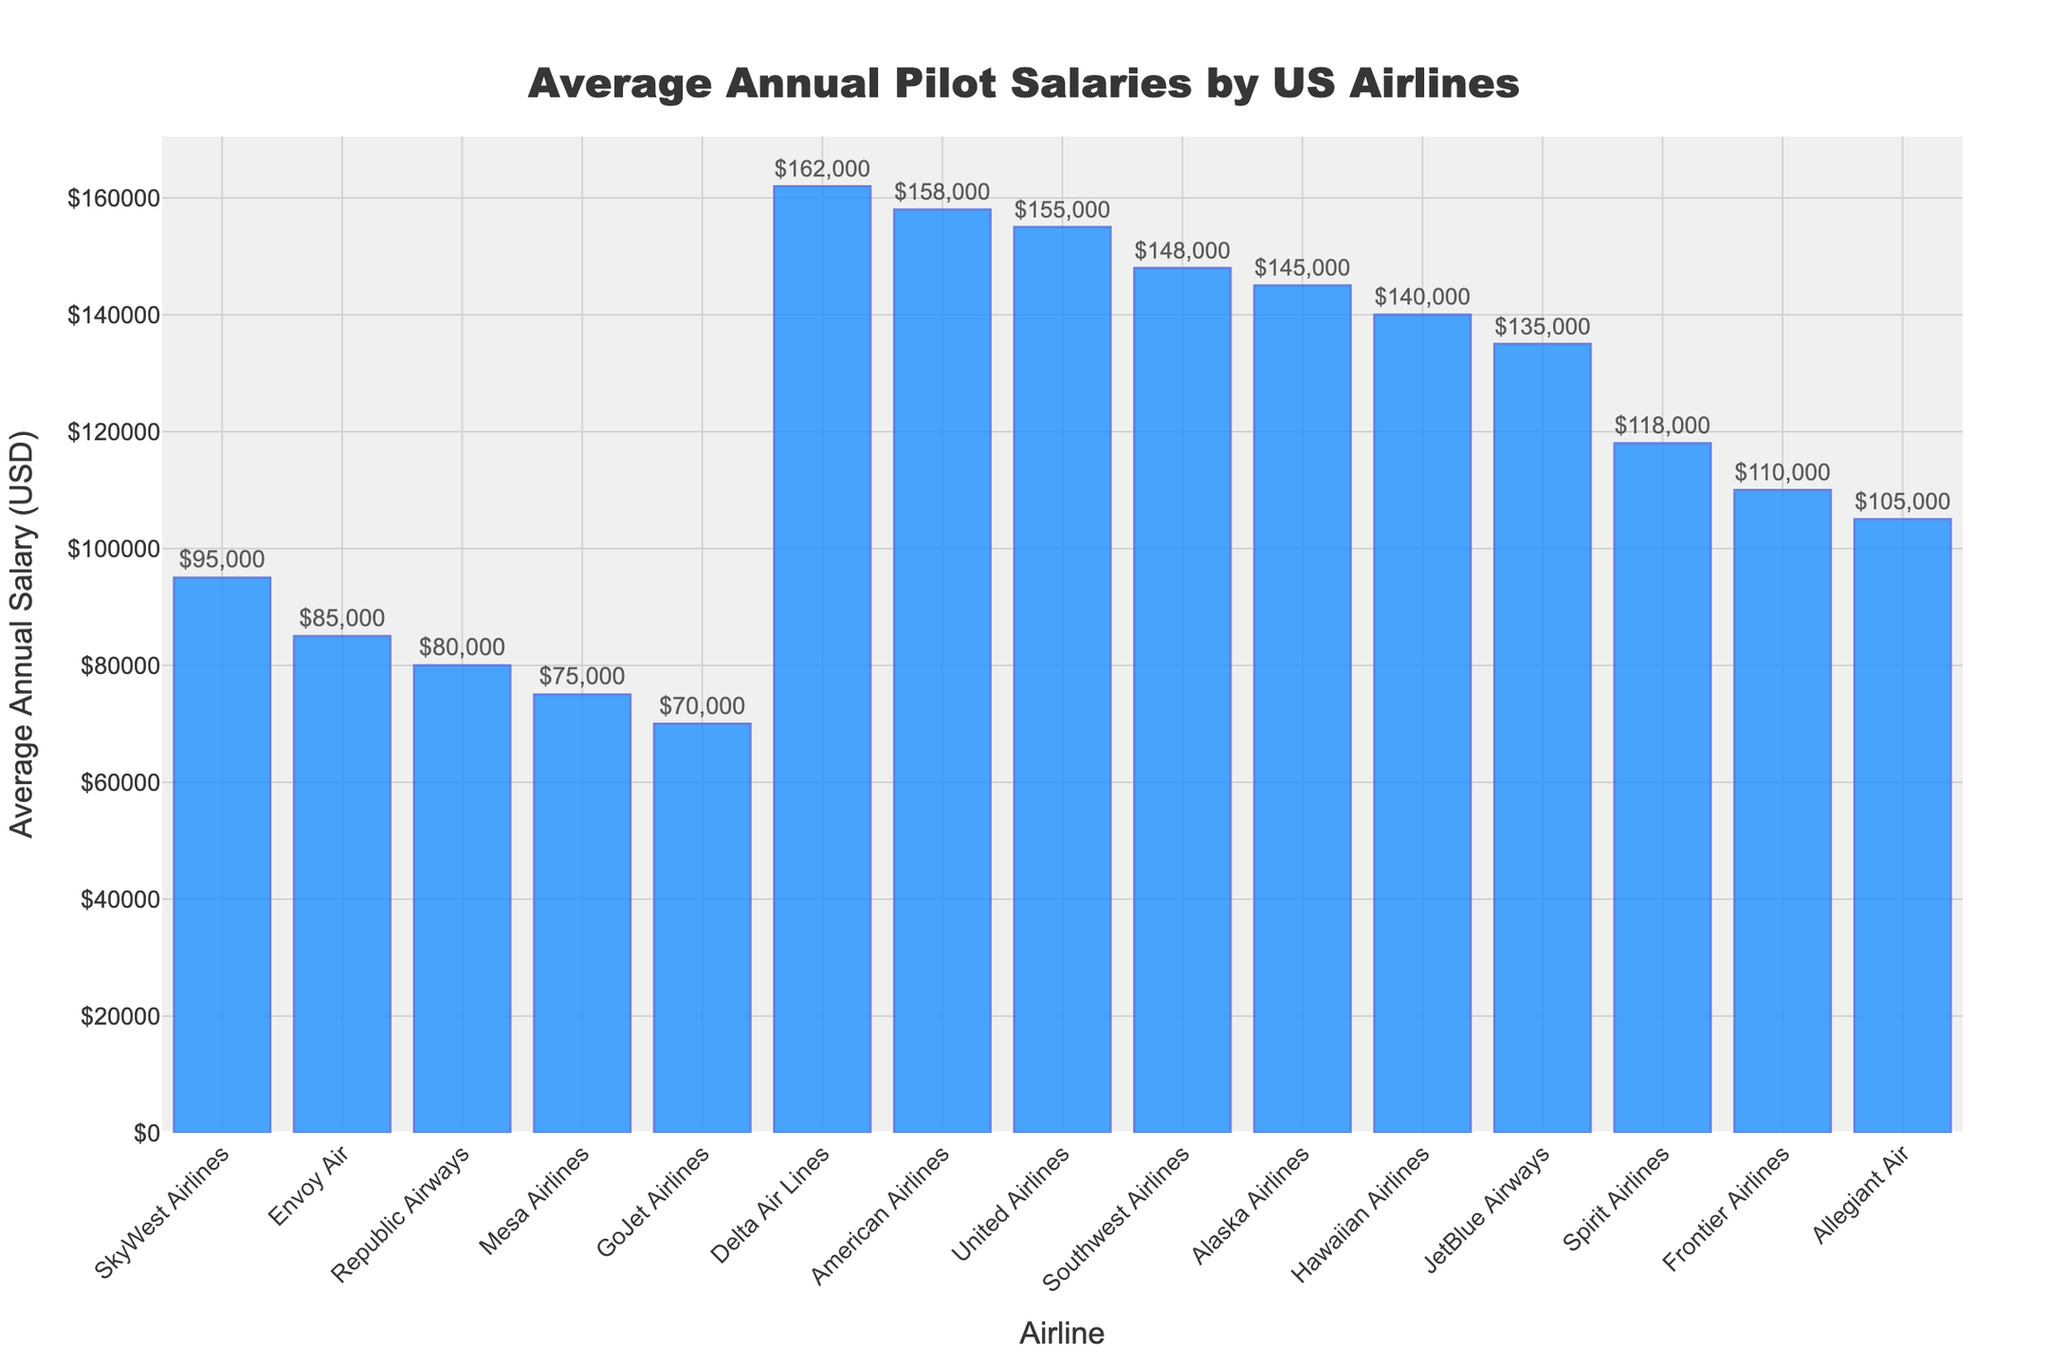Which airline pays the highest average annual salary? To determine which airline pays the highest salary, look for the tallest bar in the bar chart. The highest bar represents Delta Air Lines.
Answer: Delta Air Lines Which airline has the lowest average annual salary? Look for the shortest bar in the chart. The shortest bar corresponds to GoJet Airlines.
Answer: GoJet Airlines How much more does a pilot at Delta Air Lines make annually compared to a pilot at Frontier Airlines? Find the bars for Delta Air Lines and Frontier Airlines, then calculate the difference between their salaries: $162,000 - $110,000.
Answer: $52,000 What is the average of the top three highest salaries? Identify the top three highest bars (Delta Air Lines, American Airlines, United Airlines), sum their salaries ($162,000 + $158,000 + $155,000), and divide by three.
Answer: $158,333.33 What is the total salary of pilots from Alaska Airlines and Hawaiian Airlines combined? Find the salaries for Alaska Airlines and Hawaiian Airlines, then sum them: $145,000 + $140,000.
Answer: $285,000 How many airlines pay their pilots more than $140,000 annually? Count the bars that have salaries greater than $140,000. These are Delta Air Lines, American Airlines, United Airlines, and Southwest Airlines.
Answer: Four Which airline has a salary closest to $120,000 annually? Look for the bar nearest to $120,000. Spirit Airlines has a salary of $118,000, which is the closest.
Answer: Spirit Airlines What is the salary range (difference between highest and lowest salaries) among all the listed airlines? Subtract the lowest salary (GoJet Airlines, $70,000) from the highest salary (Delta Air Lines, $162,000): $162,000 - $70,000.
Answer: $92,000 What's the median salary of all the listed airlines? Arrange the salaries in ascending order and find the middle value. With 15 values, the median is the 8th value in the sorted list: $118,000.
Answer: $118,000 How much more does a pilot at American Airlines make compared to a pilot at SkyWest Airlines? Find the salaries for American Airlines and SkyWest Airlines, then calculate the difference: $158,000 - $95,000.
Answer: $63,000 